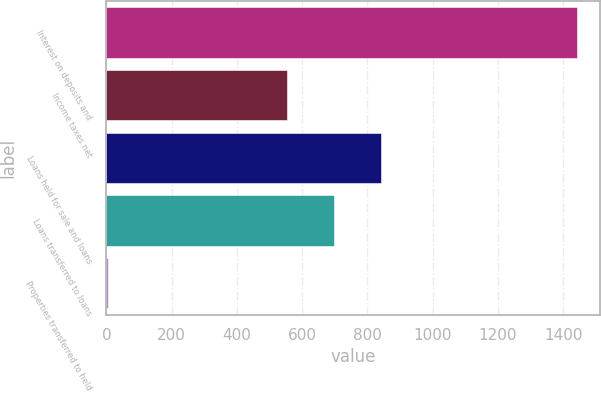Convert chart to OTSL. <chart><loc_0><loc_0><loc_500><loc_500><bar_chart><fcel>Interest on deposits and<fcel>Income taxes net<fcel>Loans held for sale and loans<fcel>Loans transferred to loans<fcel>Properties transferred to held<nl><fcel>1442<fcel>555<fcel>842.2<fcel>698.6<fcel>6<nl></chart> 